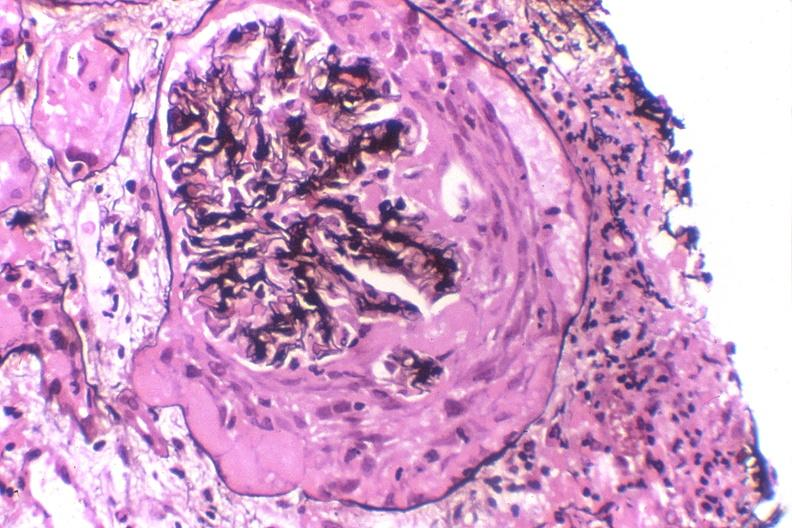do bilobed stain?
Answer the question using a single word or phrase. No 